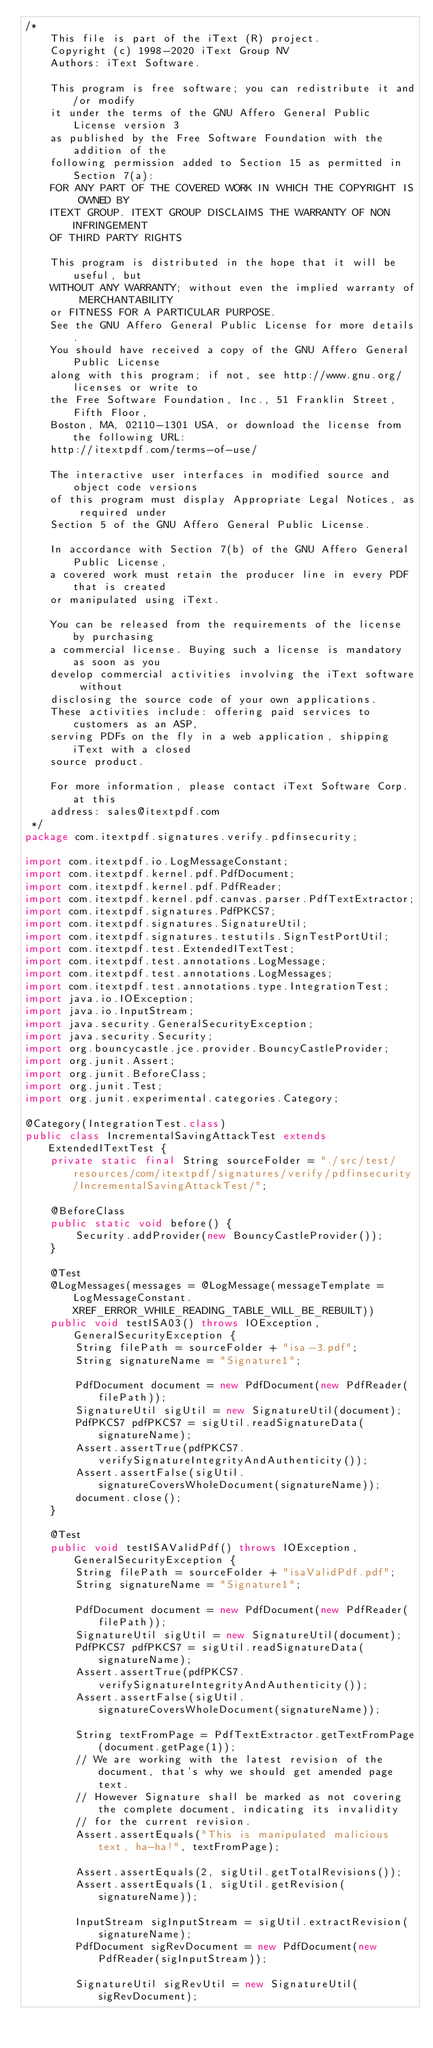Convert code to text. <code><loc_0><loc_0><loc_500><loc_500><_Java_>/*
    This file is part of the iText (R) project.
    Copyright (c) 1998-2020 iText Group NV
    Authors: iText Software.

    This program is free software; you can redistribute it and/or modify
    it under the terms of the GNU Affero General Public License version 3
    as published by the Free Software Foundation with the addition of the
    following permission added to Section 15 as permitted in Section 7(a):
    FOR ANY PART OF THE COVERED WORK IN WHICH THE COPYRIGHT IS OWNED BY
    ITEXT GROUP. ITEXT GROUP DISCLAIMS THE WARRANTY OF NON INFRINGEMENT
    OF THIRD PARTY RIGHTS

    This program is distributed in the hope that it will be useful, but
    WITHOUT ANY WARRANTY; without even the implied warranty of MERCHANTABILITY
    or FITNESS FOR A PARTICULAR PURPOSE.
    See the GNU Affero General Public License for more details.
    You should have received a copy of the GNU Affero General Public License
    along with this program; if not, see http://www.gnu.org/licenses or write to
    the Free Software Foundation, Inc., 51 Franklin Street, Fifth Floor,
    Boston, MA, 02110-1301 USA, or download the license from the following URL:
    http://itextpdf.com/terms-of-use/

    The interactive user interfaces in modified source and object code versions
    of this program must display Appropriate Legal Notices, as required under
    Section 5 of the GNU Affero General Public License.

    In accordance with Section 7(b) of the GNU Affero General Public License,
    a covered work must retain the producer line in every PDF that is created
    or manipulated using iText.

    You can be released from the requirements of the license by purchasing
    a commercial license. Buying such a license is mandatory as soon as you
    develop commercial activities involving the iText software without
    disclosing the source code of your own applications.
    These activities include: offering paid services to customers as an ASP,
    serving PDFs on the fly in a web application, shipping iText with a closed
    source product.

    For more information, please contact iText Software Corp. at this
    address: sales@itextpdf.com
 */
package com.itextpdf.signatures.verify.pdfinsecurity;

import com.itextpdf.io.LogMessageConstant;
import com.itextpdf.kernel.pdf.PdfDocument;
import com.itextpdf.kernel.pdf.PdfReader;
import com.itextpdf.kernel.pdf.canvas.parser.PdfTextExtractor;
import com.itextpdf.signatures.PdfPKCS7;
import com.itextpdf.signatures.SignatureUtil;
import com.itextpdf.signatures.testutils.SignTestPortUtil;
import com.itextpdf.test.ExtendedITextTest;
import com.itextpdf.test.annotations.LogMessage;
import com.itextpdf.test.annotations.LogMessages;
import com.itextpdf.test.annotations.type.IntegrationTest;
import java.io.IOException;
import java.io.InputStream;
import java.security.GeneralSecurityException;
import java.security.Security;
import org.bouncycastle.jce.provider.BouncyCastleProvider;
import org.junit.Assert;
import org.junit.BeforeClass;
import org.junit.Test;
import org.junit.experimental.categories.Category;

@Category(IntegrationTest.class)
public class IncrementalSavingAttackTest extends ExtendedITextTest {
    private static final String sourceFolder = "./src/test/resources/com/itextpdf/signatures/verify/pdfinsecurity/IncrementalSavingAttackTest/";

    @BeforeClass
    public static void before() {
        Security.addProvider(new BouncyCastleProvider());
    }

    @Test
    @LogMessages(messages = @LogMessage(messageTemplate = LogMessageConstant.XREF_ERROR_WHILE_READING_TABLE_WILL_BE_REBUILT))
    public void testISA03() throws IOException, GeneralSecurityException {
        String filePath = sourceFolder + "isa-3.pdf";
        String signatureName = "Signature1";

        PdfDocument document = new PdfDocument(new PdfReader(filePath));
        SignatureUtil sigUtil = new SignatureUtil(document);
        PdfPKCS7 pdfPKCS7 = sigUtil.readSignatureData(signatureName);
        Assert.assertTrue(pdfPKCS7.verifySignatureIntegrityAndAuthenticity());
        Assert.assertFalse(sigUtil.signatureCoversWholeDocument(signatureName));
        document.close();
    }

    @Test
    public void testISAValidPdf() throws IOException, GeneralSecurityException {
        String filePath = sourceFolder + "isaValidPdf.pdf";
        String signatureName = "Signature1";

        PdfDocument document = new PdfDocument(new PdfReader(filePath));
        SignatureUtil sigUtil = new SignatureUtil(document);
        PdfPKCS7 pdfPKCS7 = sigUtil.readSignatureData(signatureName);
        Assert.assertTrue(pdfPKCS7.verifySignatureIntegrityAndAuthenticity());
        Assert.assertFalse(sigUtil.signatureCoversWholeDocument(signatureName));

        String textFromPage = PdfTextExtractor.getTextFromPage(document.getPage(1));
        // We are working with the latest revision of the document, that's why we should get amended page text.
        // However Signature shall be marked as not covering the complete document, indicating its invalidity
        // for the current revision.
        Assert.assertEquals("This is manipulated malicious text, ha-ha!", textFromPage);

        Assert.assertEquals(2, sigUtil.getTotalRevisions());
        Assert.assertEquals(1, sigUtil.getRevision(signatureName));

        InputStream sigInputStream = sigUtil.extractRevision(signatureName);
        PdfDocument sigRevDocument = new PdfDocument(new PdfReader(sigInputStream));

        SignatureUtil sigRevUtil = new SignatureUtil(sigRevDocument);</code> 